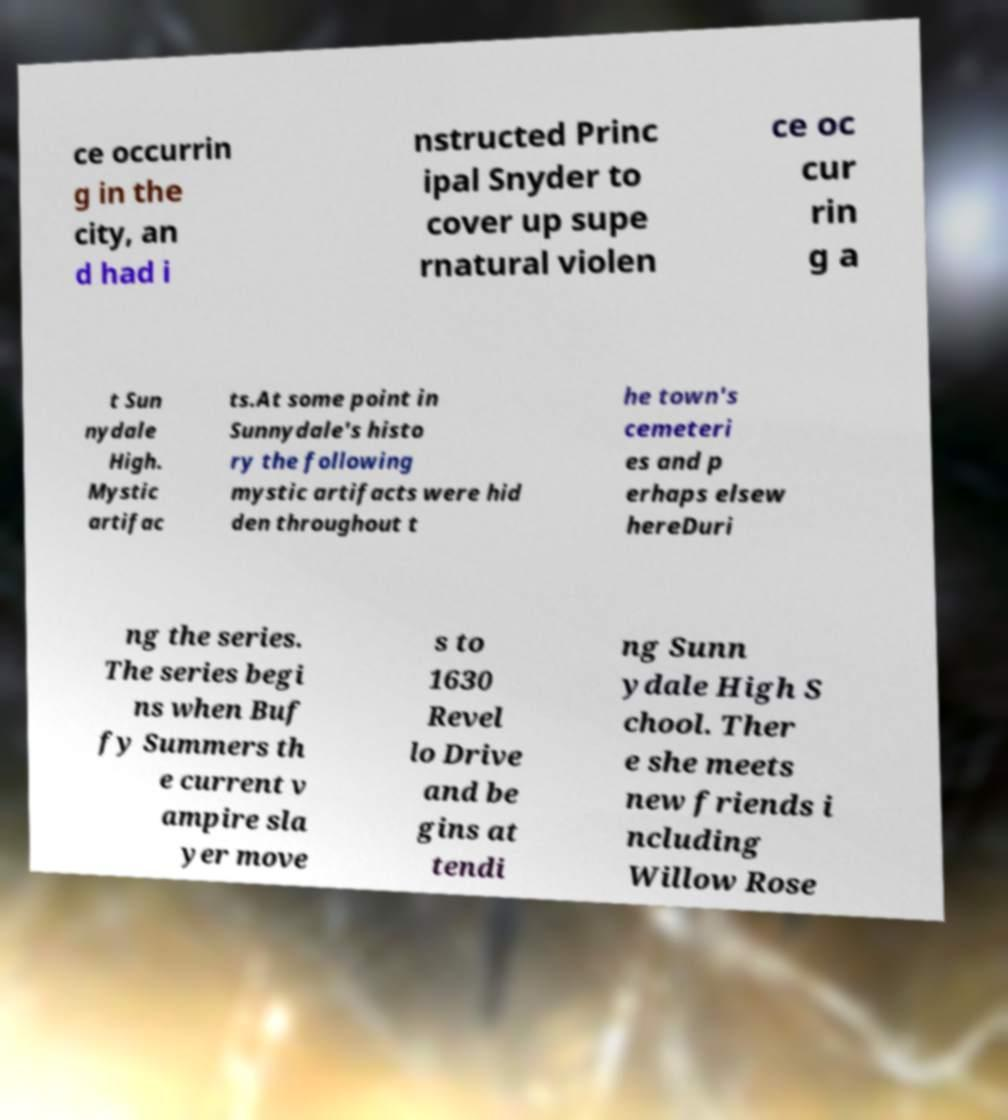For documentation purposes, I need the text within this image transcribed. Could you provide that? ce occurrin g in the city, an d had i nstructed Princ ipal Snyder to cover up supe rnatural violen ce oc cur rin g a t Sun nydale High. Mystic artifac ts.At some point in Sunnydale's histo ry the following mystic artifacts were hid den throughout t he town's cemeteri es and p erhaps elsew hereDuri ng the series. The series begi ns when Buf fy Summers th e current v ampire sla yer move s to 1630 Revel lo Drive and be gins at tendi ng Sunn ydale High S chool. Ther e she meets new friends i ncluding Willow Rose 